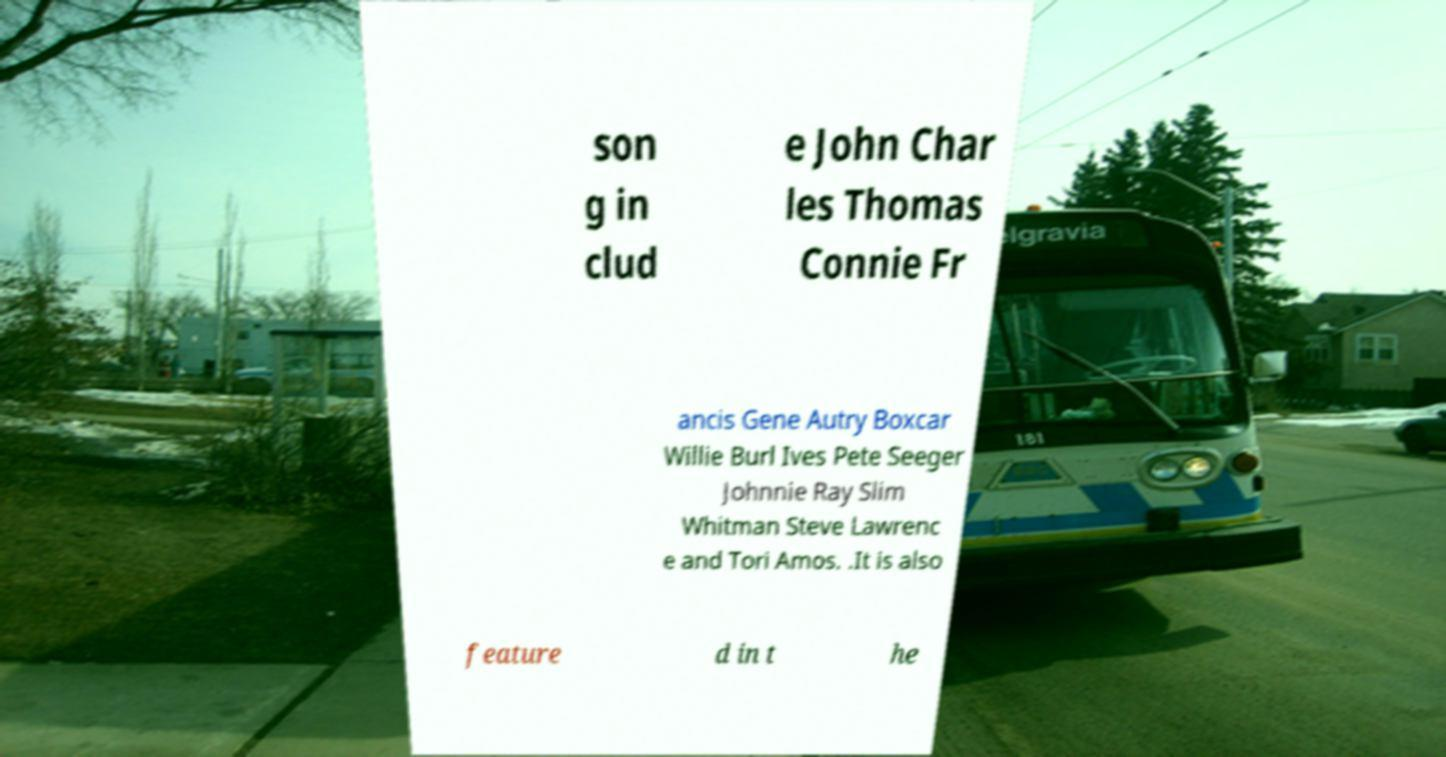Can you accurately transcribe the text from the provided image for me? son g in clud e John Char les Thomas Connie Fr ancis Gene Autry Boxcar Willie Burl Ives Pete Seeger Johnnie Ray Slim Whitman Steve Lawrenc e and Tori Amos. .It is also feature d in t he 